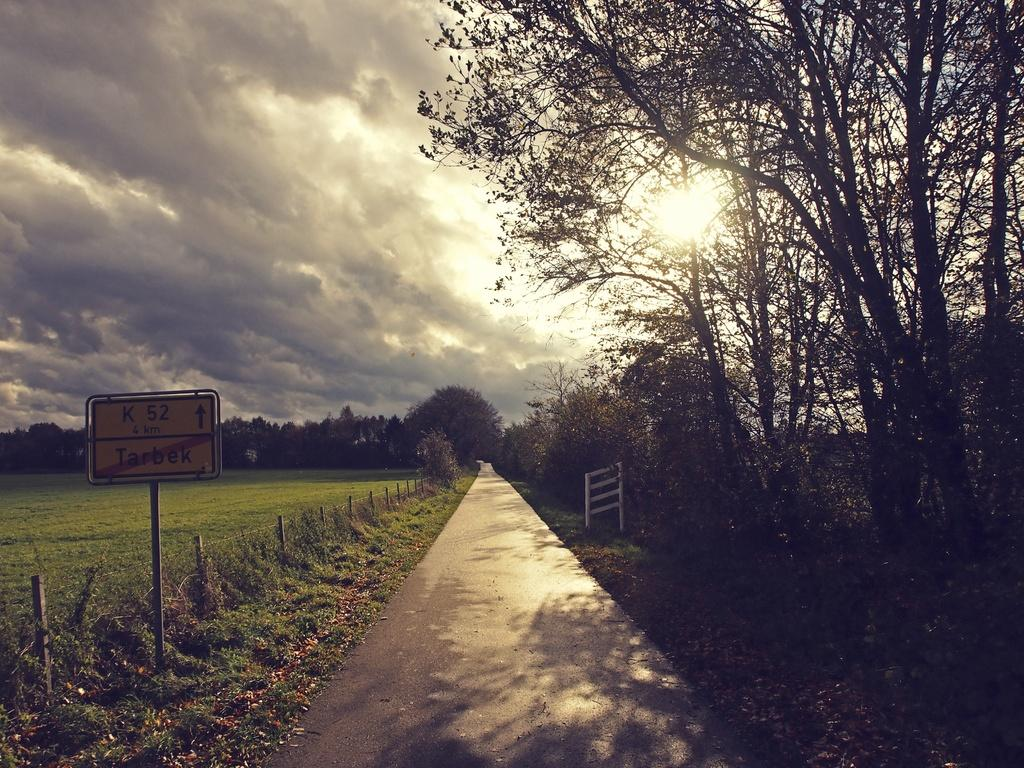What is the dominant feature in the image? There are many trees in the image. What is located at the bottom of the image? There is a road at the bottom of the image. What can be found on the right side of the image? There is a stand on the right side of the image. What is on the left side of the image? There is a board on the left side of the image. What is visible in the sky at the top of the image? There are clouds in the sky at the top of the image. What type of dog can be seen playing with a ball in the image? There is no dog or ball present in the image; it features trees, a road, a stand, a board, and clouds. 